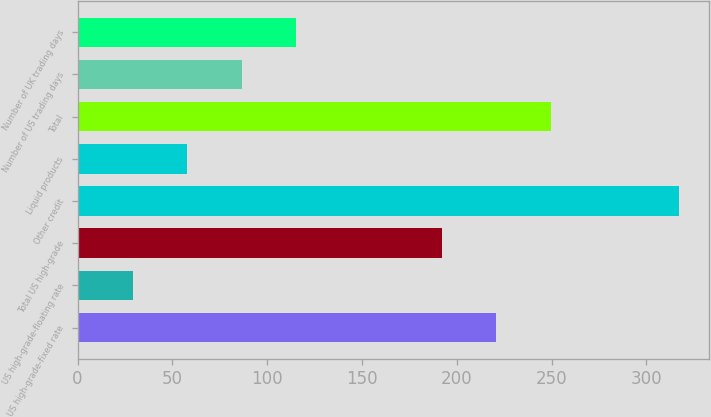Convert chart to OTSL. <chart><loc_0><loc_0><loc_500><loc_500><bar_chart><fcel>US high-grade-fixed rate<fcel>US high-grade-floating rate<fcel>Total US high-grade<fcel>Other credit<fcel>Liquid products<fcel>Total<fcel>Number of US trading days<fcel>Number of UK trading days<nl><fcel>220.8<fcel>29<fcel>192<fcel>317<fcel>57.8<fcel>249.6<fcel>86.6<fcel>115.4<nl></chart> 